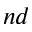Convert formula to latex. <formula><loc_0><loc_0><loc_500><loc_500>^ { n d }</formula> 